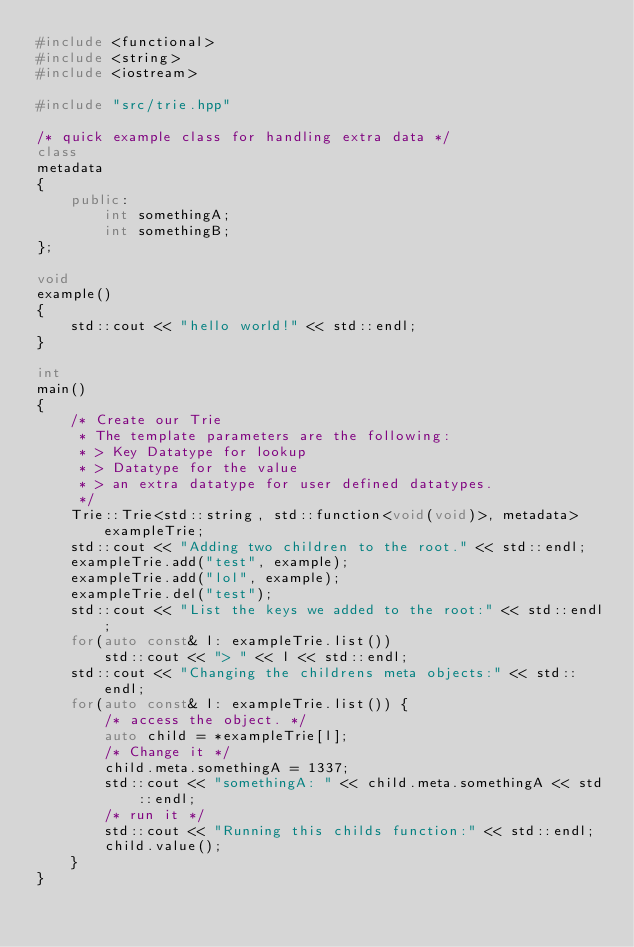<code> <loc_0><loc_0><loc_500><loc_500><_C++_>#include <functional>
#include <string>
#include <iostream>

#include "src/trie.hpp"

/* quick example class for handling extra data */
class
metadata
{
    public:
        int somethingA;
        int somethingB;    
};

void
example()
{
    std::cout << "hello world!" << std::endl;
}

int
main()
{
    /* Create our Trie
     * The template parameters are the following:
     * > Key Datatype for lookup
     * > Datatype for the value
     * > an extra datatype for user defined datatypes.
     */
    Trie::Trie<std::string, std::function<void(void)>, metadata> exampleTrie;
    std::cout << "Adding two children to the root." << std::endl;
    exampleTrie.add("test", example);
    exampleTrie.add("lol", example);
    exampleTrie.del("test");
    std::cout << "List the keys we added to the root:" << std::endl;
    for(auto const& l: exampleTrie.list())
        std::cout << "> " << l << std::endl;
    std::cout << "Changing the childrens meta objects:" << std::endl;
    for(auto const& l: exampleTrie.list()) {
        /* access the object. */
        auto child = *exampleTrie[l];
        /* Change it */
        child.meta.somethingA = 1337;
        std::cout << "somethingA: " << child.meta.somethingA << std::endl;
        /* run it */
        std::cout << "Running this childs function:" << std::endl;
        child.value();
    }
}
</code> 